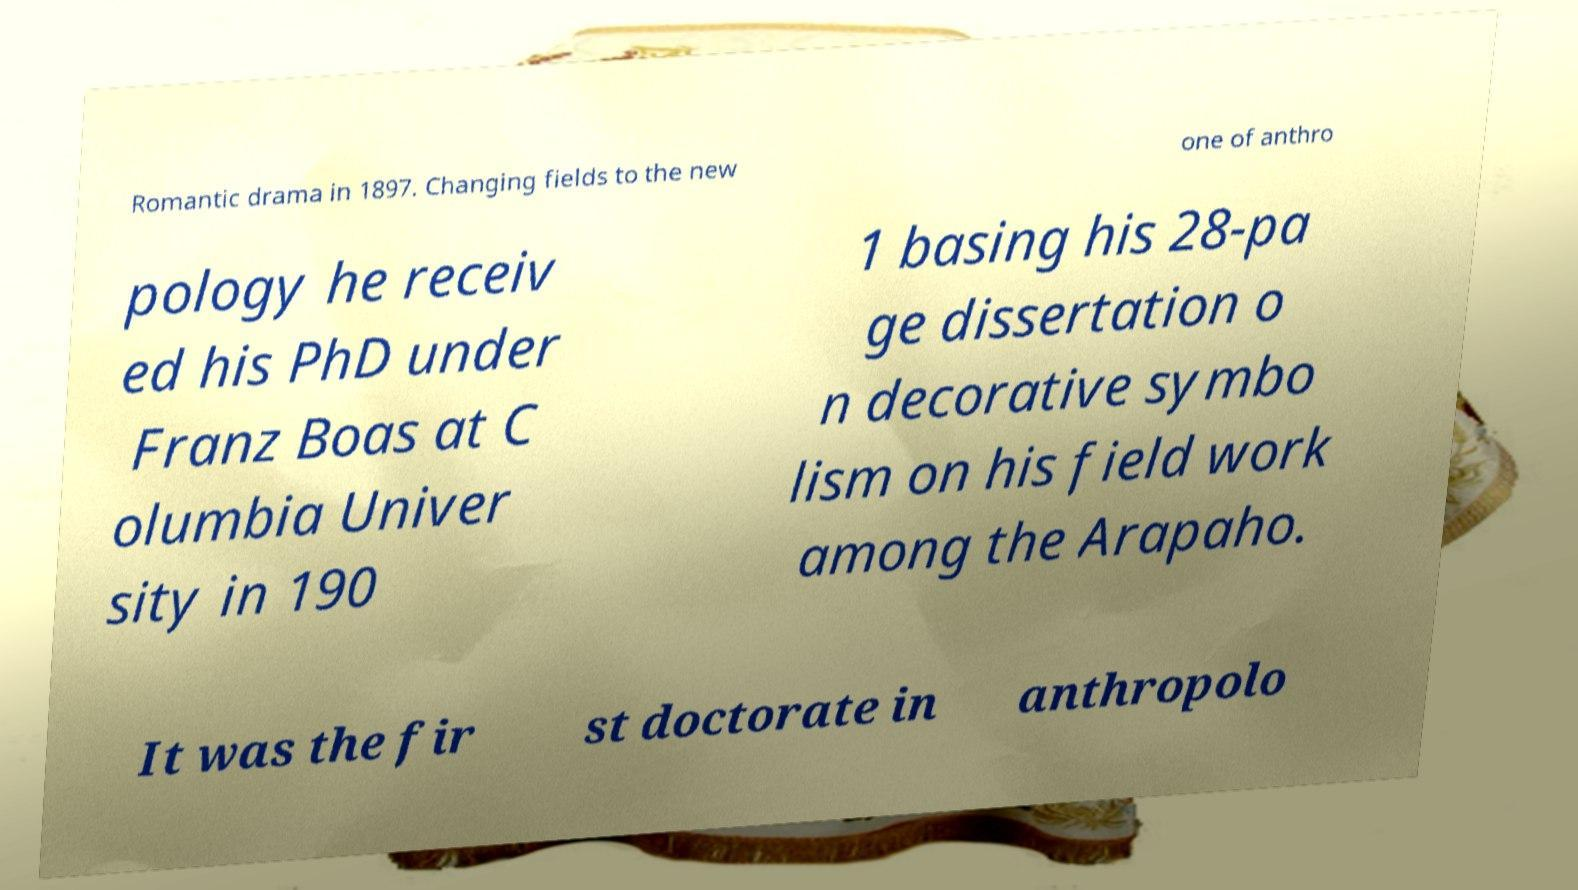Could you extract and type out the text from this image? Romantic drama in 1897. Changing fields to the new one of anthro pology he receiv ed his PhD under Franz Boas at C olumbia Univer sity in 190 1 basing his 28-pa ge dissertation o n decorative symbo lism on his field work among the Arapaho. It was the fir st doctorate in anthropolo 